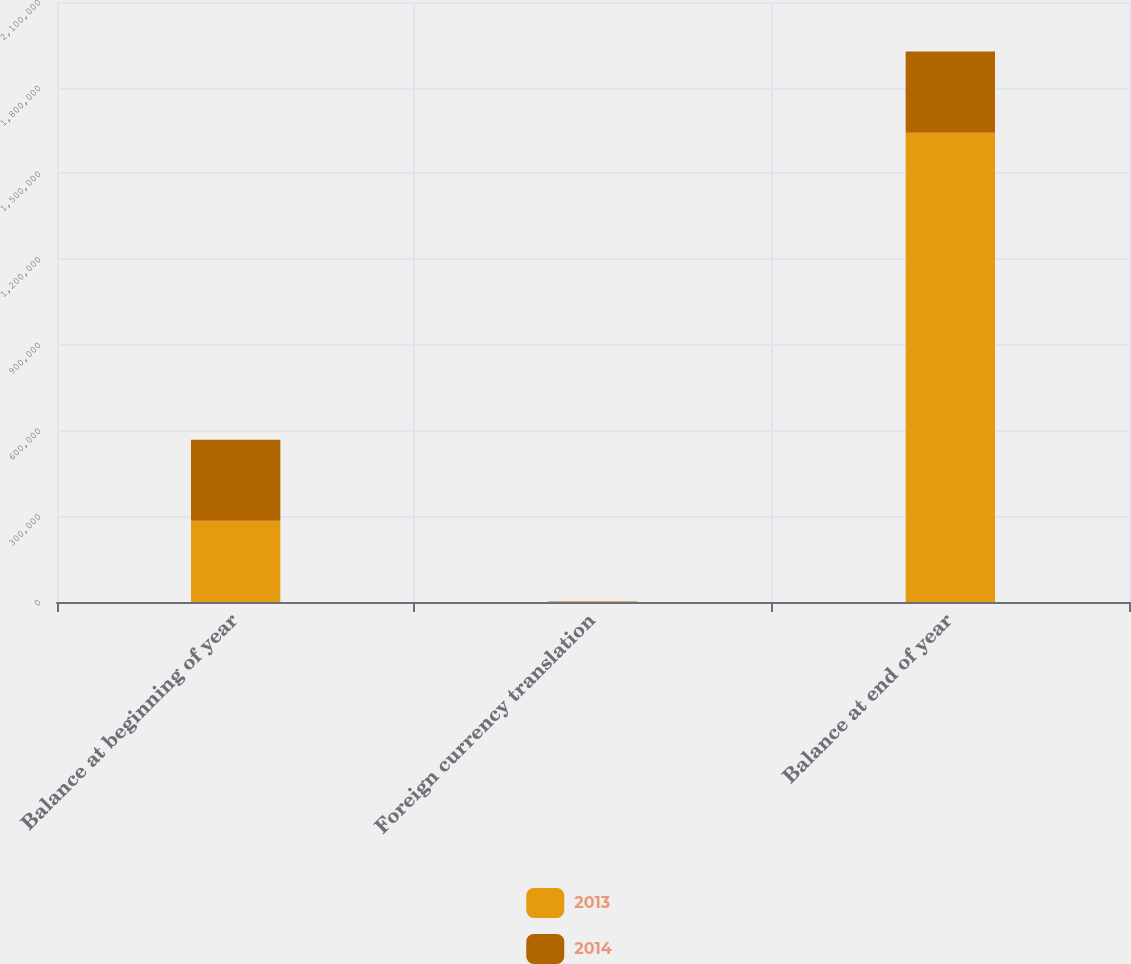Convert chart to OTSL. <chart><loc_0><loc_0><loc_500><loc_500><stacked_bar_chart><ecel><fcel>Balance at beginning of year<fcel>Foreign currency translation<fcel>Balance at end of year<nl><fcel>2013<fcel>284112<fcel>88<fcel>1.64244e+06<nl><fcel>2014<fcel>283833<fcel>1888<fcel>284112<nl></chart> 